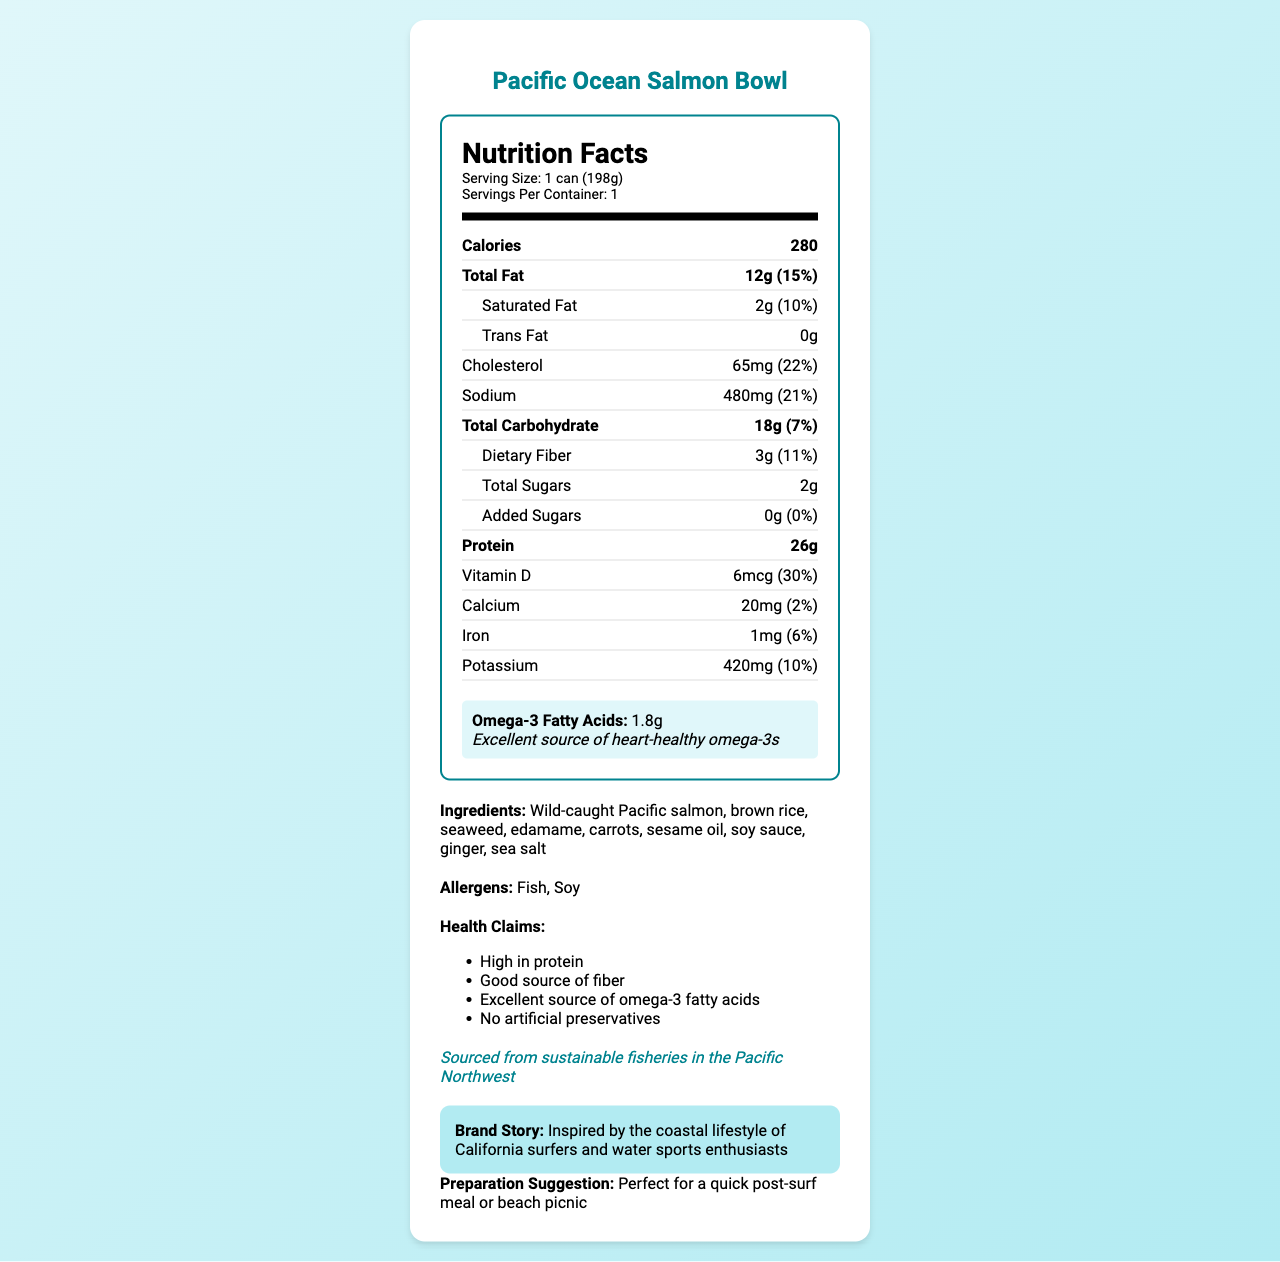what is the serving size for the Pacific Ocean Salmon Bowl? The serving size is specified as "1 can (198g)" in the serving information section.
Answer: 1 can (198g) how much cholesterol is in the Pacific Ocean Salmon Bowl per serving? The cholesterol content is listed as 65mg in the nutrition label.
Answer: 65mg What is the total fat content and its percentage daily value? The total fat content is mentioned as 12g with a 15% daily value.
Answer: 12g (15%) Name the vitamins and minerals and their respective daily values included in the Pacific Ocean Salmon Bowl. The document lists these nutrients along with their amounts and daily values.
Answer: Vitamin D: 6mcg (30%), Calcium: 20mg (2%), Iron: 1mg (6%), Potassium: 420mg (10%) What are the ingredients of the Pacific Ocean Salmon Bowl? The ingredients are listed under the ingredients section of the document.
Answer: Wild-caught Pacific salmon, brown rice, seaweed, edamame, carrots, sesame oil, soy sauce, ginger, sea salt Which health claims are made about the Pacific Ocean Salmon Bowl? A. High in protein B. Good source of fiber C. Contains artificial preservatives D. Excellent source of omega-3 fatty acids The health claims section lists 'No artificial preservatives', indicating that it does not contain them.
Answer: C. Contains artificial preservatives Which allergens are present in the Pacific Ocean Salmon Bowl? A. Dairy B. Nuts C. Fish D. Soy The allergens section lists 'Fish' and 'Soy'.
Answer: C and D (Fish and Soy) Is the Pacific Ocean Salmon Bowl a good source of omega-3 fatty acids? The document highlights that it is an excellent source of heart-healthy omega-3 fatty acids.
Answer: Yes Does the product contain any added sugars? The document states '0g' for added sugars in the nutrition facts.
Answer: No Summarize the main idea of the document. The document includes comprehensive information covering the product's nutritional values, ingredients, allergens, and claims about health benefits, sourcing, and brand inspiration.
Answer: The document provides detailed nutrition, ingredients, allergens, health claims, sustainability info, brand story, and preparation suggestion for the Pacific Ocean Salmon Bowl, highlighting its high protein, good fiber, and excellent omega-3 content sourced from sustainable fisheries. What is the recommended preparation suggestion? The preparation suggestion is explicitly stated in the document.
Answer: Perfect for a quick post-surf meal or beach picnic Does the product have a high amount of dietary fiber? The dietary fiber content is 3g, which is 11% of the daily value, indicating a relatively high amount of fiber.
Answer: Relatively high Do we know the market price of the Pacific Ocean Salmon Bowl from the document? The document does not provide any price details.
Answer: Not enough information 